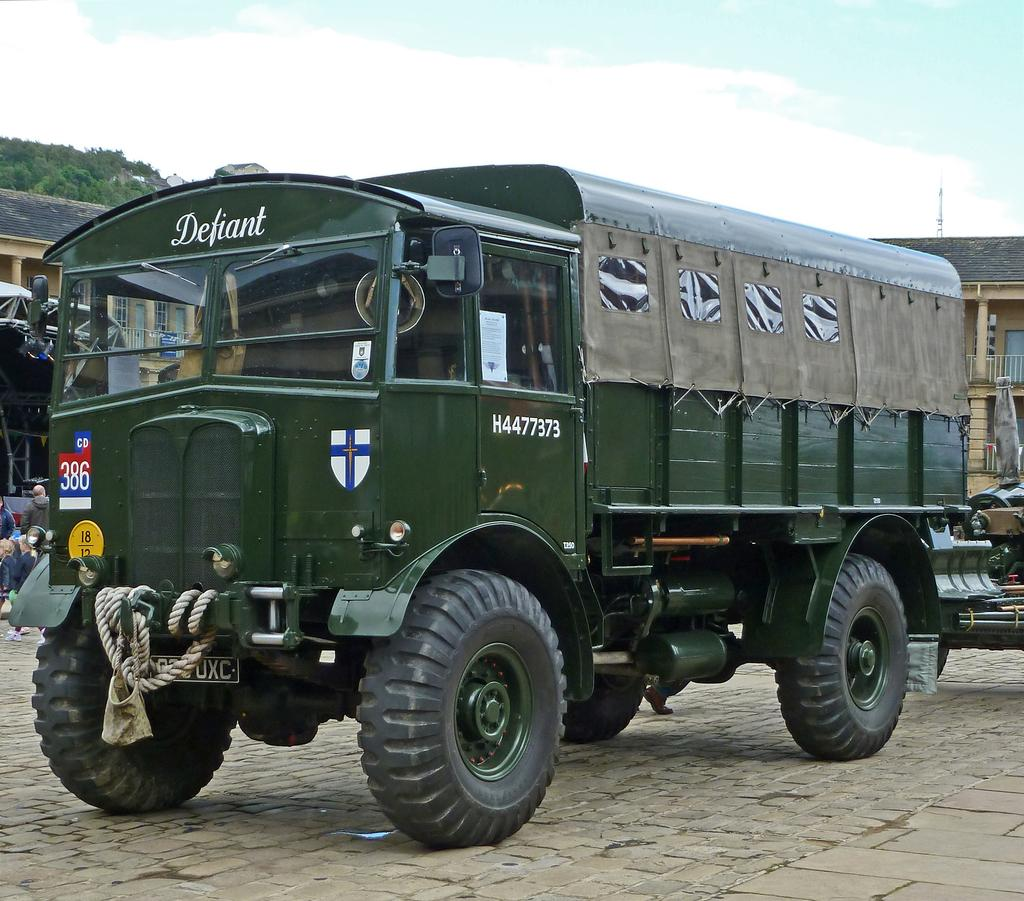What is the main subject in the center of the image? There is a truck in the center of the image. Where is the truck located? The truck is on the road. What can be seen in the background of the image? There are buildings, trees, and the sky visible in the background of the image. Are there any people present in the image? Yes, there are people on the left side of the image. What type of degree is the truck driver holding in the image? There is no indication of a truck driver or any degrees in the image. What books are the people on the left side of the image reading? There are no books visible in the image. 